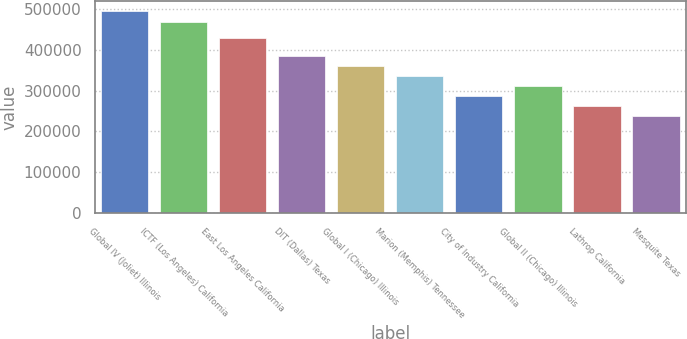Convert chart to OTSL. <chart><loc_0><loc_0><loc_500><loc_500><bar_chart><fcel>Global IV (Joliet) Illinois<fcel>ICTF (Los Angeles) California<fcel>East Los Angeles California<fcel>DIT (Dallas) Texas<fcel>Global I (Chicago) Illinois<fcel>Marion (Memphis) Tennessee<fcel>City of Industry California<fcel>Global II (Chicago) Illinois<fcel>Lathrop California<fcel>Mesquite Texas<nl><fcel>493600<fcel>469000<fcel>429000<fcel>385600<fcel>361000<fcel>336400<fcel>287200<fcel>311800<fcel>262600<fcel>238000<nl></chart> 